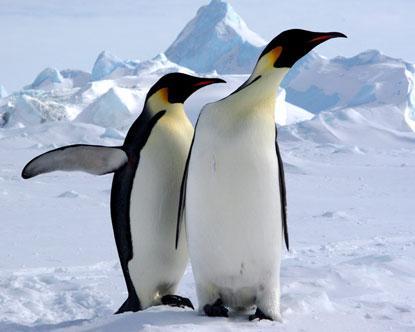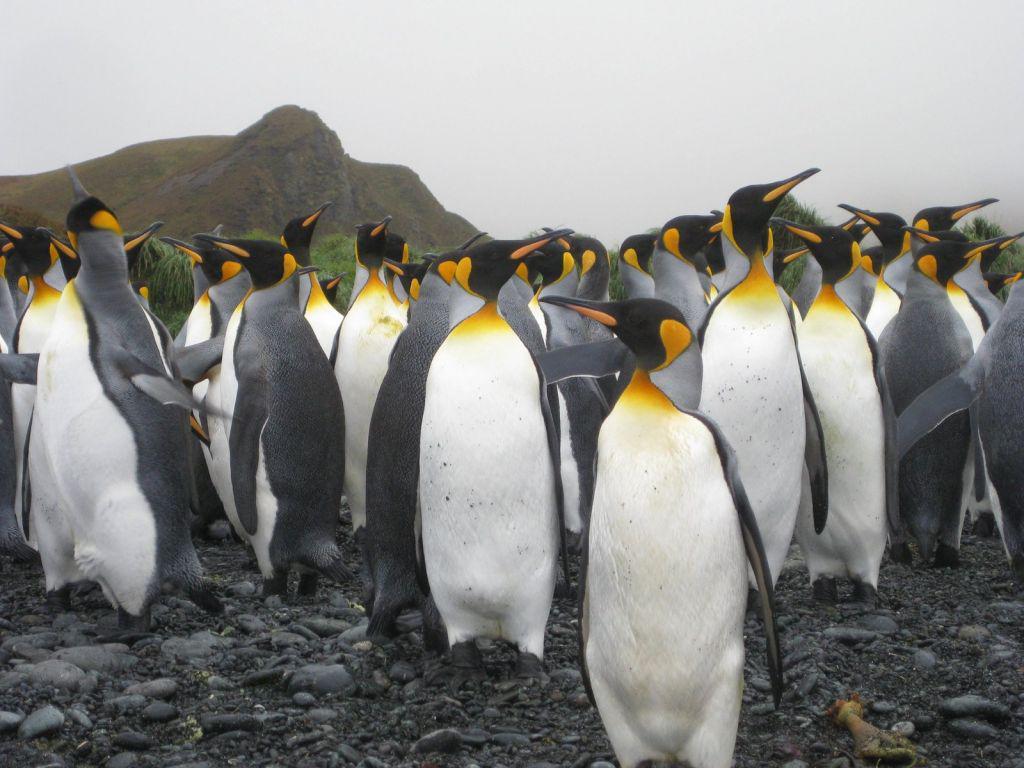The first image is the image on the left, the second image is the image on the right. Considering the images on both sides, is "An image shows two foreground penguins with furry patches." valid? Answer yes or no. No. The first image is the image on the left, the second image is the image on the right. For the images shown, is this caption "At least one image shows only two penguins." true? Answer yes or no. Yes. The first image is the image on the left, the second image is the image on the right. For the images displayed, is the sentence "There is one image with two penguins standing on ice." factually correct? Answer yes or no. Yes. The first image is the image on the left, the second image is the image on the right. Considering the images on both sides, is "One of the pictures has only two penguins." valid? Answer yes or no. Yes. 